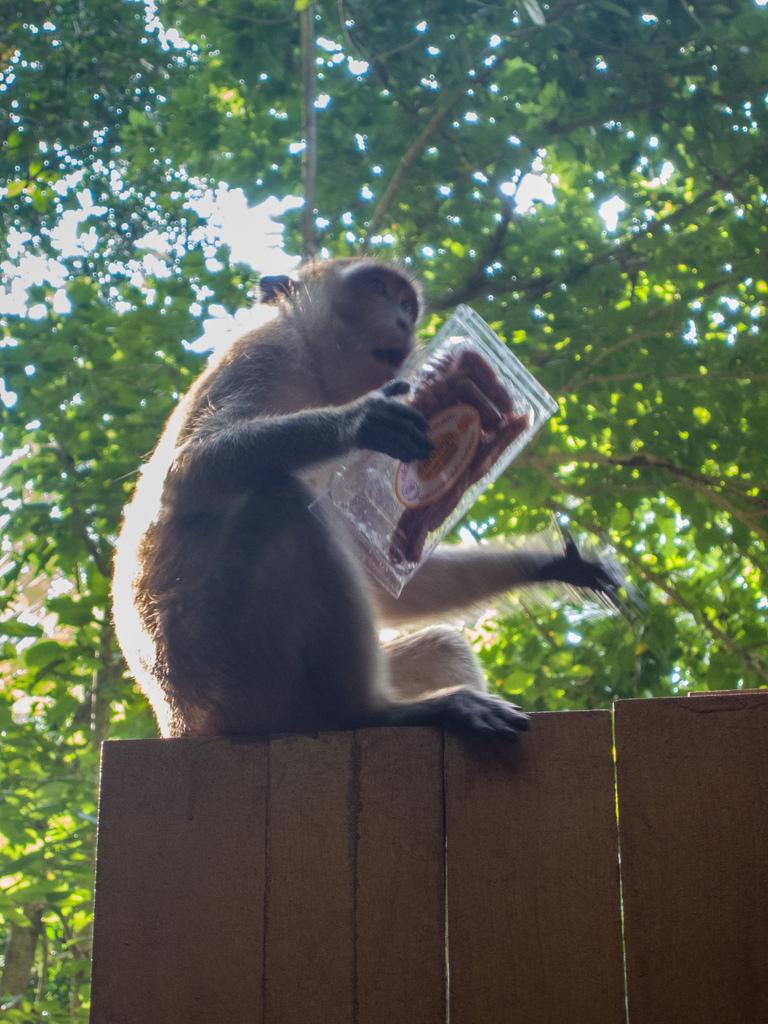What animal is present in the image? There is a monkey in the image. What is the monkey doing in the image? The monkey is sitting in the image. What is the monkey holding in the image? The monkey is holding a box in the image. What can be seen in the background of the image? There are trees and the sky visible in the background of the image. What type of appliance can be seen in the image? There is no appliance present in the image; it features a monkey sitting and holding a box. 